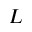<formula> <loc_0><loc_0><loc_500><loc_500>L</formula> 